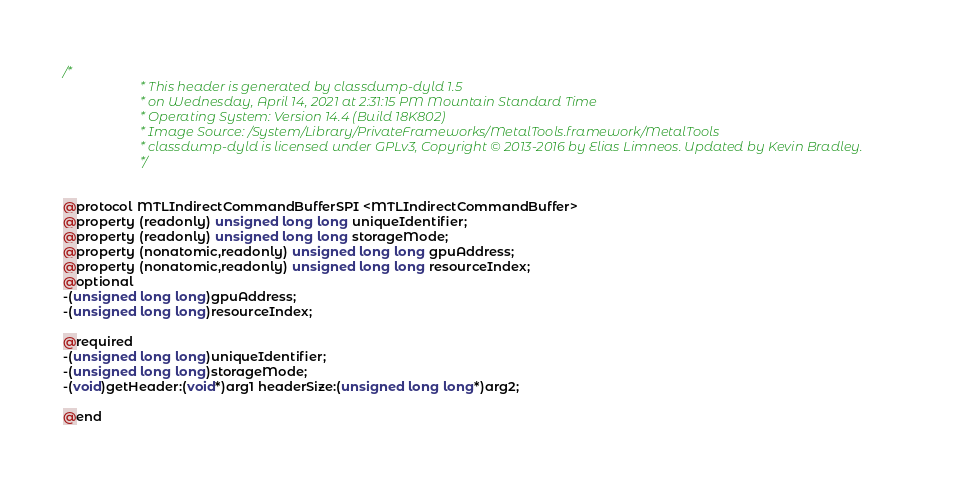Convert code to text. <code><loc_0><loc_0><loc_500><loc_500><_C_>/*
                       * This header is generated by classdump-dyld 1.5
                       * on Wednesday, April 14, 2021 at 2:31:15 PM Mountain Standard Time
                       * Operating System: Version 14.4 (Build 18K802)
                       * Image Source: /System/Library/PrivateFrameworks/MetalTools.framework/MetalTools
                       * classdump-dyld is licensed under GPLv3, Copyright © 2013-2016 by Elias Limneos. Updated by Kevin Bradley.
                       */


@protocol MTLIndirectCommandBufferSPI <MTLIndirectCommandBuffer>
@property (readonly) unsigned long long uniqueIdentifier; 
@property (readonly) unsigned long long storageMode; 
@property (nonatomic,readonly) unsigned long long gpuAddress; 
@property (nonatomic,readonly) unsigned long long resourceIndex; 
@optional
-(unsigned long long)gpuAddress;
-(unsigned long long)resourceIndex;

@required
-(unsigned long long)uniqueIdentifier;
-(unsigned long long)storageMode;
-(void)getHeader:(void*)arg1 headerSize:(unsigned long long*)arg2;

@end

</code> 